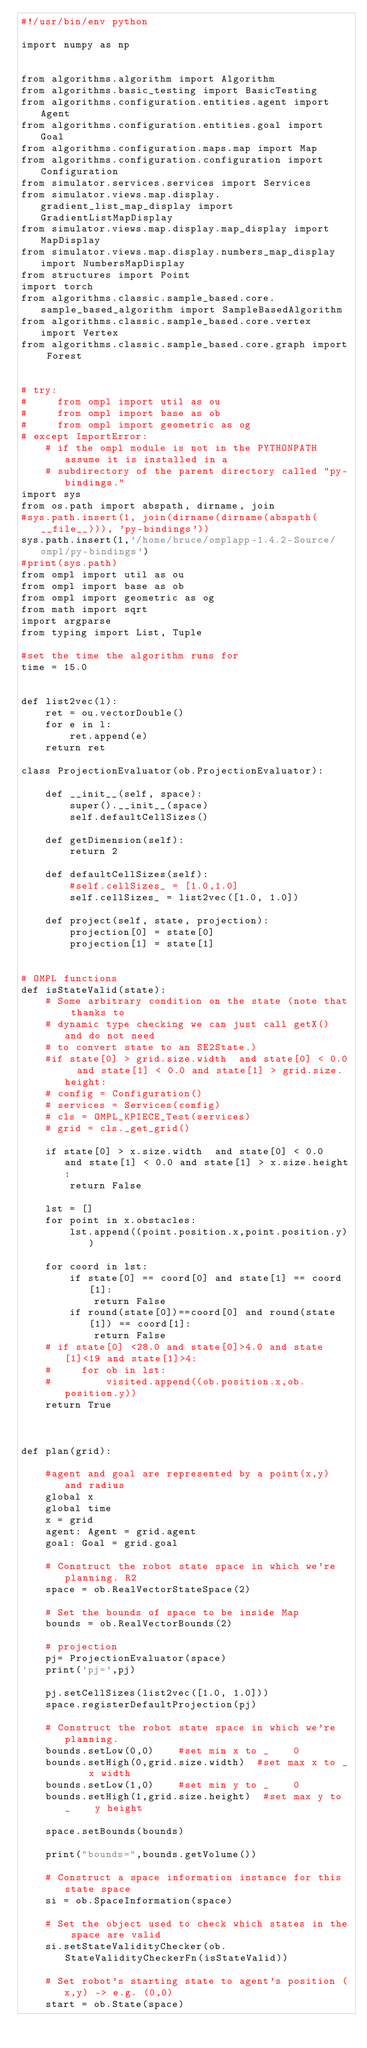Convert code to text. <code><loc_0><loc_0><loc_500><loc_500><_Python_>#!/usr/bin/env python
  
import numpy as np


from algorithms.algorithm import Algorithm
from algorithms.basic_testing import BasicTesting
from algorithms.configuration.entities.agent import Agent
from algorithms.configuration.entities.goal import Goal
from algorithms.configuration.maps.map import Map
from algorithms.configuration.configuration import Configuration
from simulator.services.services import Services
from simulator.views.map.display.gradient_list_map_display import GradientListMapDisplay
from simulator.views.map.display.map_display import MapDisplay
from simulator.views.map.display.numbers_map_display import NumbersMapDisplay
from structures import Point
import torch
from algorithms.classic.sample_based.core.sample_based_algorithm import SampleBasedAlgorithm
from algorithms.classic.sample_based.core.vertex import Vertex
from algorithms.classic.sample_based.core.graph import Forest


# try:
#     from ompl import util as ou
#     from ompl import base as ob
#     from ompl import geometric as og
# except ImportError:
    # if the ompl module is not in the PYTHONPATH assume it is installed in a
    # subdirectory of the parent directory called "py-bindings."
import sys    
from os.path import abspath, dirname, join
#sys.path.insert(1, join(dirname(dirname(abspath(__file__))), 'py-bindings'))
sys.path.insert(1,'/home/bruce/omplapp-1.4.2-Source/ompl/py-bindings')
#print(sys.path)
from ompl import util as ou
from ompl import base as ob
from ompl import geometric as og
from math import sqrt
import argparse
from typing import List, Tuple

#set the time the algorithm runs for
time = 15.0


def list2vec(l):
    ret = ou.vectorDouble()
    for e in l:
        ret.append(e)
    return ret

class ProjectionEvaluator(ob.ProjectionEvaluator):
    
    def __init__(self, space):
        super().__init__(space)
        self.defaultCellSizes()

    def getDimension(self):
        return 2

    def defaultCellSizes(self):
        #self.cellSizes_ = [1.0,1.0]
        self.cellSizes_ = list2vec([1.0, 1.0])

    def project(self, state, projection):
        projection[0] = state[0]
        projection[1] = state[1]


# OMPL functions
def isStateValid(state):
    # Some arbitrary condition on the state (note that thanks to
    # dynamic type checking we can just call getX() and do not need
    # to convert state to an SE2State.)
    #if state[0] > grid.size.width  and state[0] < 0.0  and state[1] < 0.0 and state[1] > grid.size.height:
    # config = Configuration()
    # services = Services(config)   
    # cls = OMPL_KPIECE_Test(services)
    # grid = cls._get_grid()

    if state[0] > x.size.width  and state[0] < 0.0  and state[1] < 0.0 and state[1] > x.size.height:
        return False

    lst = []
    for point in x.obstacles:
        lst.append((point.position.x,point.position.y))
        
    for coord in lst:
        if state[0] == coord[0] and state[1] == coord[1]:
            return False
        if round(state[0])==coord[0] and round(state[1]) == coord[1]:
            return False
    # if state[0] <28.0 and state[0]>4.0 and state[1]<19 and state[1]>4:
    #     for ob in lst:
    #         visited.append((ob.position.x,ob.position.y))   
    return True



def plan(grid):

    #agent and goal are represented by a point(x,y) and radius
    global x
    global time
    x = grid
    agent: Agent = grid.agent
    goal: Goal = grid.goal

    # Construct the robot state space in which we're planning. R2
    space = ob.RealVectorStateSpace(2)

    # Set the bounds of space to be inside Map
    bounds = ob.RealVectorBounds(2)

    # projection
    pj= ProjectionEvaluator(space)
    print('pj=',pj)
  
    pj.setCellSizes(list2vec([1.0, 1.0]))
    space.registerDefaultProjection(pj)

    # Construct the robot state space in which we're planning.
    bounds.setLow(0,0)    #set min x to _    0
    bounds.setHigh(0,grid.size.width)  #set max x to _    x width 
    bounds.setLow(1,0)    #set min y to _    0
    bounds.setHigh(1,grid.size.height)  #set max y to _    y height

    space.setBounds(bounds)

    print("bounds=",bounds.getVolume())

    # Construct a space information instance for this state space
    si = ob.SpaceInformation(space)

    # Set the object used to check which states in the space are valid
    si.setStateValidityChecker(ob.StateValidityCheckerFn(isStateValid))

    # Set robot's starting state to agent's position (x,y) -> e.g. (0,0)
    start = ob.State(space)</code> 